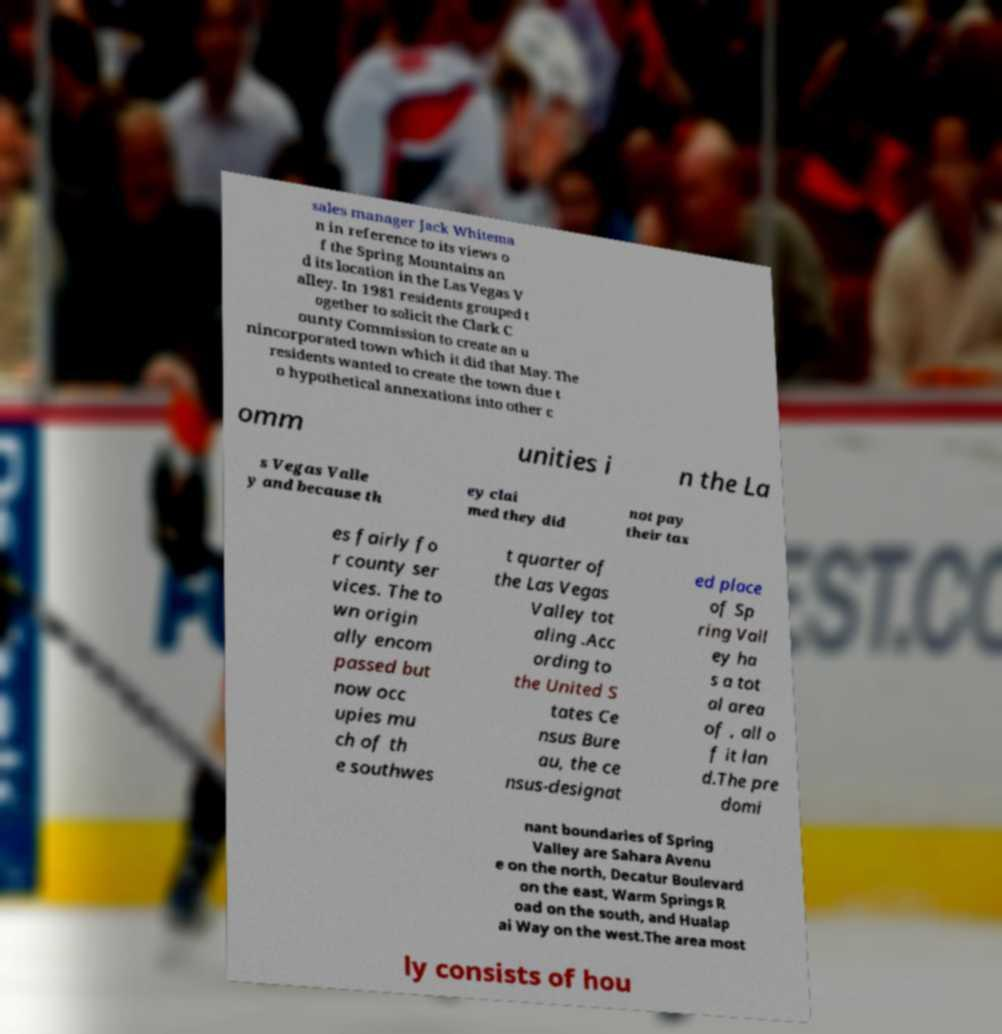For documentation purposes, I need the text within this image transcribed. Could you provide that? sales manager Jack Whitema n in reference to its views o f the Spring Mountains an d its location in the Las Vegas V alley. In 1981 residents grouped t ogether to solicit the Clark C ounty Commission to create an u nincorporated town which it did that May. The residents wanted to create the town due t o hypothetical annexations into other c omm unities i n the La s Vegas Valle y and because th ey clai med they did not pay their tax es fairly fo r county ser vices. The to wn origin ally encom passed but now occ upies mu ch of th e southwes t quarter of the Las Vegas Valley tot aling .Acc ording to the United S tates Ce nsus Bure au, the ce nsus-designat ed place of Sp ring Vall ey ha s a tot al area of , all o f it lan d.The pre domi nant boundaries of Spring Valley are Sahara Avenu e on the north, Decatur Boulevard on the east, Warm Springs R oad on the south, and Hualap ai Way on the west.The area most ly consists of hou 